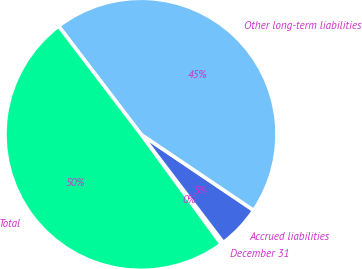Convert chart. <chart><loc_0><loc_0><loc_500><loc_500><pie_chart><fcel>December 31<fcel>Accrued liabilities<fcel>Other long-term liabilities<fcel>Total<nl><fcel>0.31%<fcel>5.2%<fcel>44.8%<fcel>49.69%<nl></chart> 